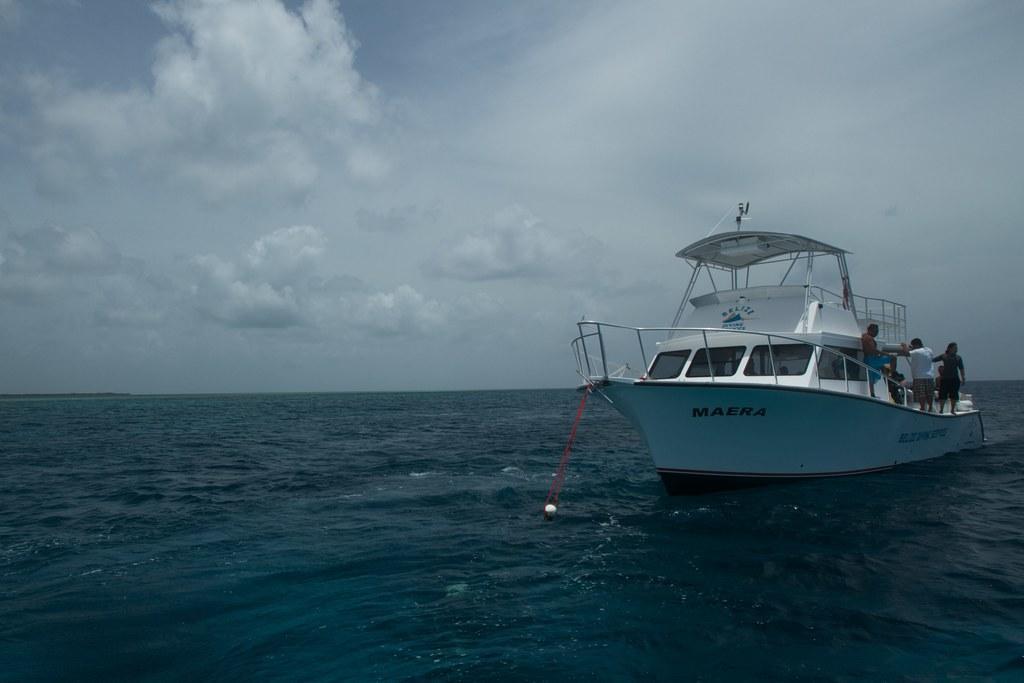Describe this image in one or two sentences. As we can see in the image there is water, boat, few people, sky and clouds. 